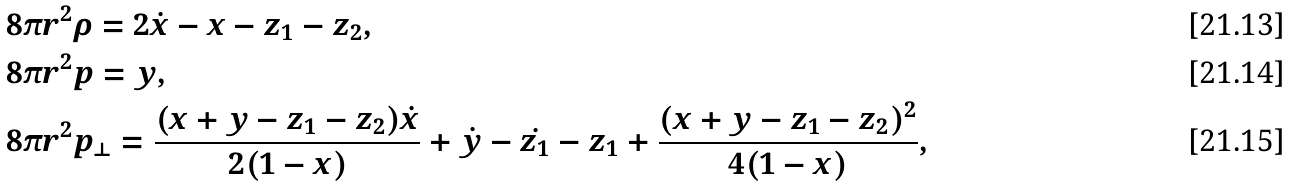<formula> <loc_0><loc_0><loc_500><loc_500>& 8 \pi r ^ { 2 } \rho = 2 \dot { x } - x - z _ { 1 } - z _ { 2 } , \\ & 8 \pi r ^ { 2 } p = y , \\ & 8 \pi r ^ { 2 } p _ { \perp } = \frac { ( x + y - z _ { 1 } - z _ { 2 } ) \dot { x } } { 2 ( 1 - x ) } + \dot { y } - \dot { z _ { 1 } } - z _ { 1 } + \frac { ( x + y - z _ { 1 } - z _ { 2 } ) ^ { 2 } } { 4 ( 1 - x ) } ,</formula> 